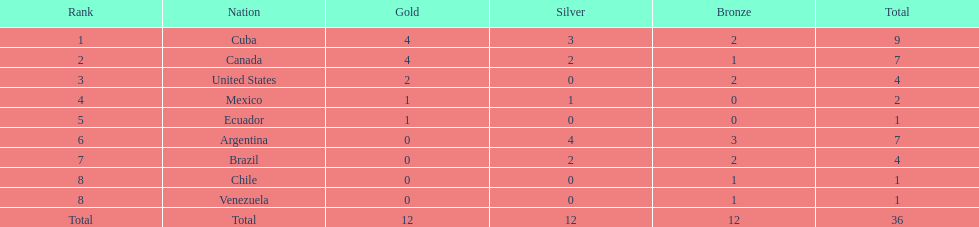Can you parse all the data within this table? {'header': ['Rank', 'Nation', 'Gold', 'Silver', 'Bronze', 'Total'], 'rows': [['1', 'Cuba', '4', '3', '2', '9'], ['2', 'Canada', '4', '2', '1', '7'], ['3', 'United States', '2', '0', '2', '4'], ['4', 'Mexico', '1', '1', '0', '2'], ['5', 'Ecuador', '1', '0', '0', '1'], ['6', 'Argentina', '0', '4', '3', '7'], ['7', 'Brazil', '0', '2', '2', '4'], ['8', 'Chile', '0', '0', '1', '1'], ['8', 'Venezuela', '0', '0', '1', '1'], ['Total', 'Total', '12', '12', '12', '36']]} In which nation did they achieve the gold medal without winning silver? United States. 